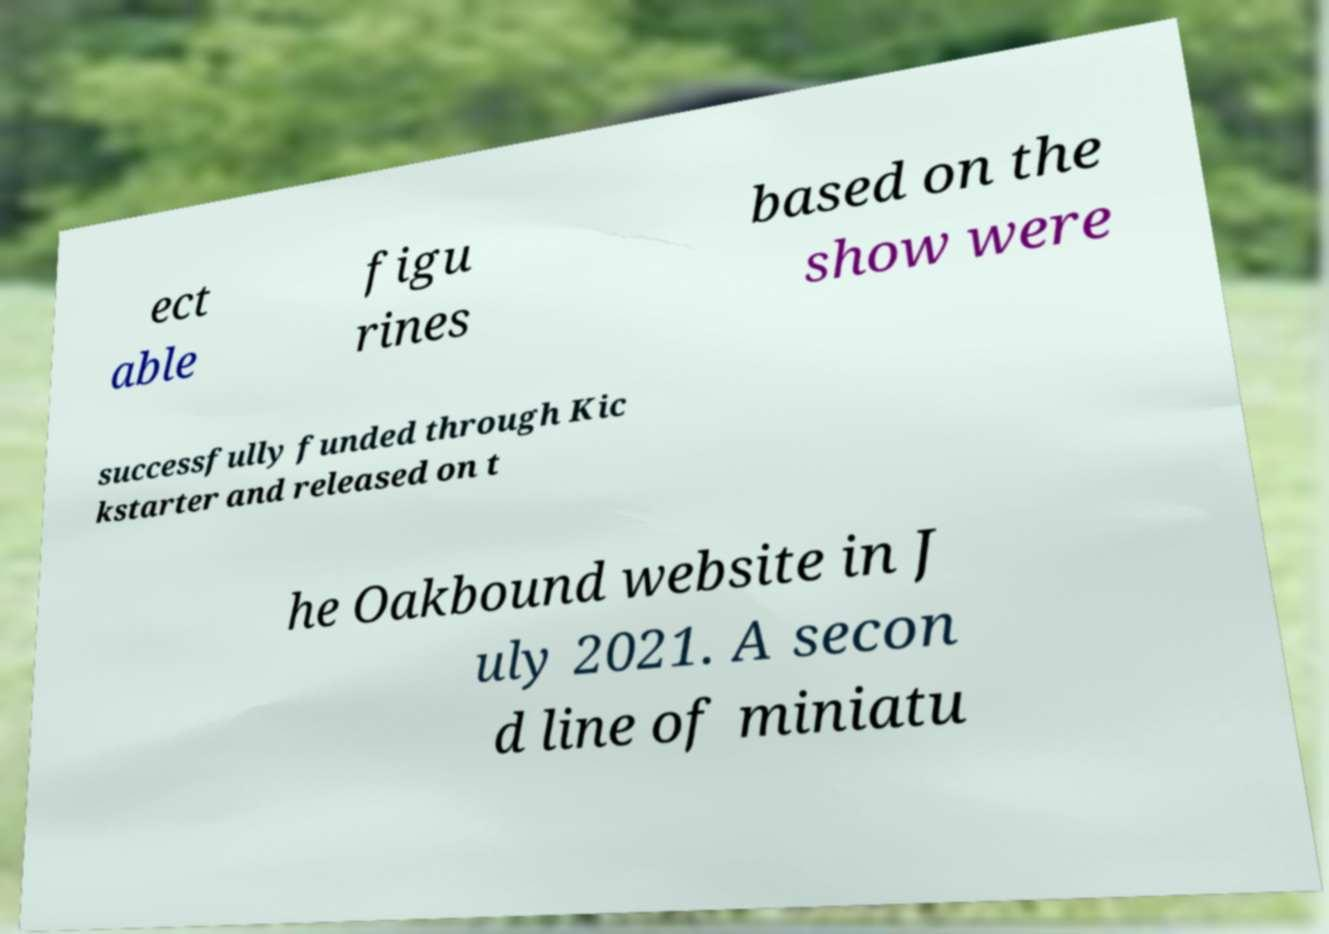Can you accurately transcribe the text from the provided image for me? ect able figu rines based on the show were successfully funded through Kic kstarter and released on t he Oakbound website in J uly 2021. A secon d line of miniatu 